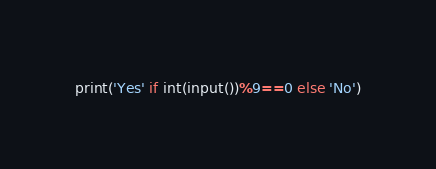<code> <loc_0><loc_0><loc_500><loc_500><_Python_>print('Yes' if int(input())%9==0 else 'No')</code> 